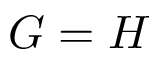Convert formula to latex. <formula><loc_0><loc_0><loc_500><loc_500>G = H</formula> 